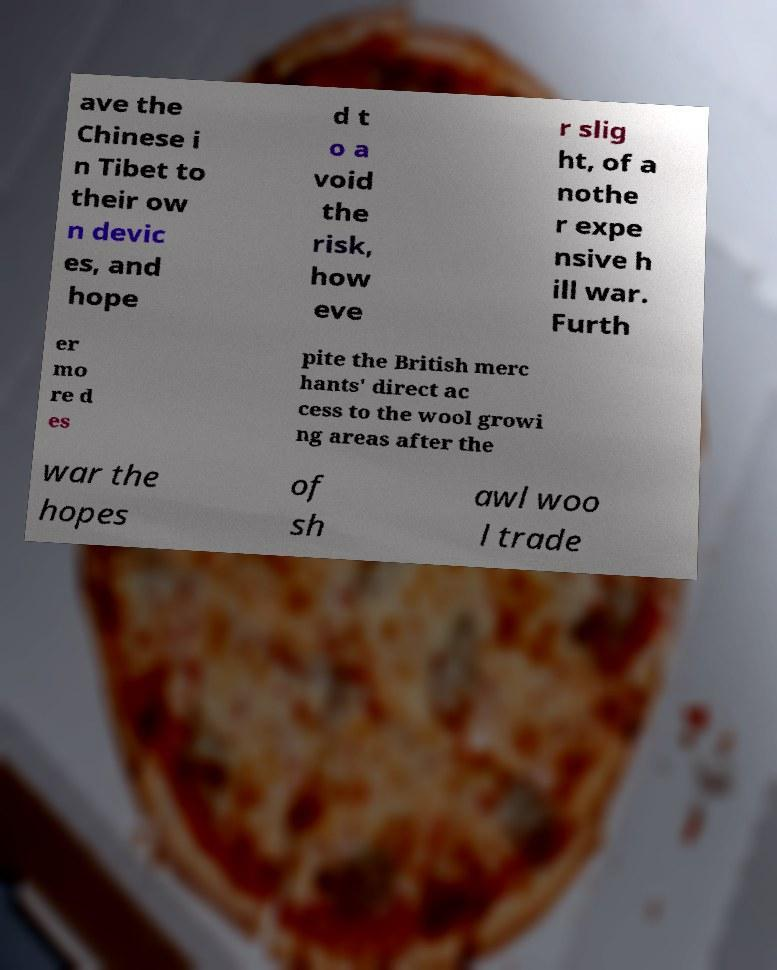Can you read and provide the text displayed in the image?This photo seems to have some interesting text. Can you extract and type it out for me? ave the Chinese i n Tibet to their ow n devic es, and hope d t o a void the risk, how eve r slig ht, of a nothe r expe nsive h ill war. Furth er mo re d es pite the British merc hants' direct ac cess to the wool growi ng areas after the war the hopes of sh awl woo l trade 